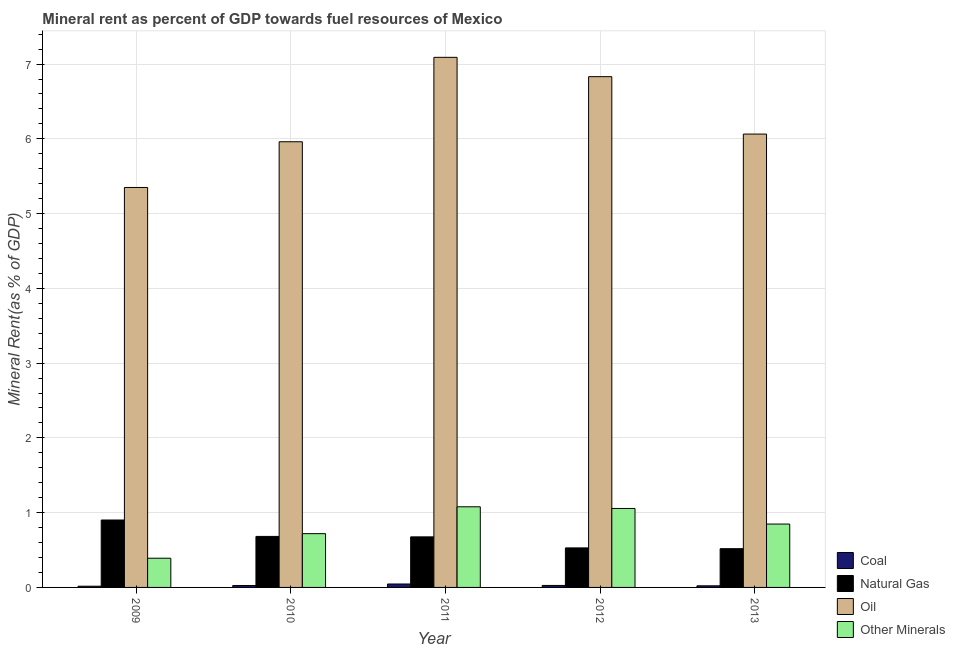How many groups of bars are there?
Give a very brief answer. 5. Are the number of bars per tick equal to the number of legend labels?
Provide a succinct answer. Yes. What is the label of the 4th group of bars from the left?
Make the answer very short. 2012. In how many cases, is the number of bars for a given year not equal to the number of legend labels?
Give a very brief answer. 0. What is the oil rent in 2009?
Offer a terse response. 5.35. Across all years, what is the maximum natural gas rent?
Provide a succinct answer. 0.9. Across all years, what is the minimum natural gas rent?
Offer a very short reply. 0.52. In which year was the oil rent maximum?
Your answer should be very brief. 2011. In which year was the natural gas rent minimum?
Your response must be concise. 2013. What is the total natural gas rent in the graph?
Provide a short and direct response. 3.31. What is the difference between the oil rent in 2011 and that in 2013?
Provide a short and direct response. 1.03. What is the difference between the natural gas rent in 2010 and the oil rent in 2011?
Provide a succinct answer. 0.01. What is the average natural gas rent per year?
Your answer should be compact. 0.66. In how many years, is the oil rent greater than 2.4 %?
Provide a short and direct response. 5. What is the ratio of the  rent of other minerals in 2009 to that in 2012?
Provide a succinct answer. 0.37. Is the natural gas rent in 2009 less than that in 2011?
Make the answer very short. No. What is the difference between the highest and the second highest coal rent?
Your response must be concise. 0.02. What is the difference between the highest and the lowest oil rent?
Your answer should be compact. 1.74. In how many years, is the natural gas rent greater than the average natural gas rent taken over all years?
Offer a terse response. 3. Is the sum of the coal rent in 2010 and 2013 greater than the maximum  rent of other minerals across all years?
Keep it short and to the point. Yes. What does the 2nd bar from the left in 2011 represents?
Offer a terse response. Natural Gas. What does the 1st bar from the right in 2010 represents?
Make the answer very short. Other Minerals. Is it the case that in every year, the sum of the coal rent and natural gas rent is greater than the oil rent?
Your answer should be very brief. No. How many years are there in the graph?
Keep it short and to the point. 5. Are the values on the major ticks of Y-axis written in scientific E-notation?
Offer a terse response. No. How many legend labels are there?
Your answer should be very brief. 4. What is the title of the graph?
Provide a succinct answer. Mineral rent as percent of GDP towards fuel resources of Mexico. What is the label or title of the Y-axis?
Ensure brevity in your answer.  Mineral Rent(as % of GDP). What is the Mineral Rent(as % of GDP) in Coal in 2009?
Make the answer very short. 0.02. What is the Mineral Rent(as % of GDP) of Natural Gas in 2009?
Your answer should be very brief. 0.9. What is the Mineral Rent(as % of GDP) in Oil in 2009?
Keep it short and to the point. 5.35. What is the Mineral Rent(as % of GDP) in Other Minerals in 2009?
Your answer should be compact. 0.39. What is the Mineral Rent(as % of GDP) in Coal in 2010?
Give a very brief answer. 0.03. What is the Mineral Rent(as % of GDP) in Natural Gas in 2010?
Your answer should be compact. 0.68. What is the Mineral Rent(as % of GDP) in Oil in 2010?
Provide a succinct answer. 5.96. What is the Mineral Rent(as % of GDP) of Other Minerals in 2010?
Your answer should be very brief. 0.72. What is the Mineral Rent(as % of GDP) of Coal in 2011?
Your answer should be very brief. 0.05. What is the Mineral Rent(as % of GDP) in Natural Gas in 2011?
Provide a short and direct response. 0.68. What is the Mineral Rent(as % of GDP) in Oil in 2011?
Offer a very short reply. 7.09. What is the Mineral Rent(as % of GDP) of Other Minerals in 2011?
Offer a terse response. 1.08. What is the Mineral Rent(as % of GDP) in Coal in 2012?
Your answer should be very brief. 0.03. What is the Mineral Rent(as % of GDP) in Natural Gas in 2012?
Provide a succinct answer. 0.53. What is the Mineral Rent(as % of GDP) of Oil in 2012?
Keep it short and to the point. 6.83. What is the Mineral Rent(as % of GDP) of Other Minerals in 2012?
Provide a short and direct response. 1.06. What is the Mineral Rent(as % of GDP) of Coal in 2013?
Your response must be concise. 0.02. What is the Mineral Rent(as % of GDP) in Natural Gas in 2013?
Offer a very short reply. 0.52. What is the Mineral Rent(as % of GDP) of Oil in 2013?
Offer a terse response. 6.06. What is the Mineral Rent(as % of GDP) of Other Minerals in 2013?
Your response must be concise. 0.85. Across all years, what is the maximum Mineral Rent(as % of GDP) of Coal?
Your answer should be compact. 0.05. Across all years, what is the maximum Mineral Rent(as % of GDP) of Natural Gas?
Your answer should be compact. 0.9. Across all years, what is the maximum Mineral Rent(as % of GDP) in Oil?
Provide a succinct answer. 7.09. Across all years, what is the maximum Mineral Rent(as % of GDP) in Other Minerals?
Provide a succinct answer. 1.08. Across all years, what is the minimum Mineral Rent(as % of GDP) in Coal?
Ensure brevity in your answer.  0.02. Across all years, what is the minimum Mineral Rent(as % of GDP) of Natural Gas?
Your response must be concise. 0.52. Across all years, what is the minimum Mineral Rent(as % of GDP) in Oil?
Make the answer very short. 5.35. Across all years, what is the minimum Mineral Rent(as % of GDP) of Other Minerals?
Your response must be concise. 0.39. What is the total Mineral Rent(as % of GDP) in Coal in the graph?
Provide a succinct answer. 0.14. What is the total Mineral Rent(as % of GDP) in Natural Gas in the graph?
Make the answer very short. 3.31. What is the total Mineral Rent(as % of GDP) in Oil in the graph?
Offer a terse response. 31.3. What is the total Mineral Rent(as % of GDP) of Other Minerals in the graph?
Provide a short and direct response. 4.09. What is the difference between the Mineral Rent(as % of GDP) in Coal in 2009 and that in 2010?
Provide a short and direct response. -0.01. What is the difference between the Mineral Rent(as % of GDP) in Natural Gas in 2009 and that in 2010?
Ensure brevity in your answer.  0.22. What is the difference between the Mineral Rent(as % of GDP) in Oil in 2009 and that in 2010?
Offer a very short reply. -0.61. What is the difference between the Mineral Rent(as % of GDP) of Other Minerals in 2009 and that in 2010?
Offer a very short reply. -0.33. What is the difference between the Mineral Rent(as % of GDP) in Coal in 2009 and that in 2011?
Offer a very short reply. -0.03. What is the difference between the Mineral Rent(as % of GDP) of Natural Gas in 2009 and that in 2011?
Offer a very short reply. 0.23. What is the difference between the Mineral Rent(as % of GDP) of Oil in 2009 and that in 2011?
Ensure brevity in your answer.  -1.74. What is the difference between the Mineral Rent(as % of GDP) of Other Minerals in 2009 and that in 2011?
Your answer should be very brief. -0.69. What is the difference between the Mineral Rent(as % of GDP) in Coal in 2009 and that in 2012?
Give a very brief answer. -0.01. What is the difference between the Mineral Rent(as % of GDP) of Natural Gas in 2009 and that in 2012?
Your response must be concise. 0.37. What is the difference between the Mineral Rent(as % of GDP) of Oil in 2009 and that in 2012?
Provide a short and direct response. -1.48. What is the difference between the Mineral Rent(as % of GDP) in Other Minerals in 2009 and that in 2012?
Provide a succinct answer. -0.67. What is the difference between the Mineral Rent(as % of GDP) of Coal in 2009 and that in 2013?
Provide a succinct answer. -0.01. What is the difference between the Mineral Rent(as % of GDP) of Natural Gas in 2009 and that in 2013?
Provide a succinct answer. 0.38. What is the difference between the Mineral Rent(as % of GDP) in Oil in 2009 and that in 2013?
Ensure brevity in your answer.  -0.71. What is the difference between the Mineral Rent(as % of GDP) in Other Minerals in 2009 and that in 2013?
Make the answer very short. -0.46. What is the difference between the Mineral Rent(as % of GDP) of Coal in 2010 and that in 2011?
Provide a succinct answer. -0.02. What is the difference between the Mineral Rent(as % of GDP) of Natural Gas in 2010 and that in 2011?
Offer a very short reply. 0.01. What is the difference between the Mineral Rent(as % of GDP) of Oil in 2010 and that in 2011?
Offer a terse response. -1.13. What is the difference between the Mineral Rent(as % of GDP) in Other Minerals in 2010 and that in 2011?
Your answer should be compact. -0.36. What is the difference between the Mineral Rent(as % of GDP) of Coal in 2010 and that in 2012?
Provide a short and direct response. -0. What is the difference between the Mineral Rent(as % of GDP) in Natural Gas in 2010 and that in 2012?
Offer a very short reply. 0.15. What is the difference between the Mineral Rent(as % of GDP) in Oil in 2010 and that in 2012?
Offer a terse response. -0.87. What is the difference between the Mineral Rent(as % of GDP) of Other Minerals in 2010 and that in 2012?
Your answer should be very brief. -0.34. What is the difference between the Mineral Rent(as % of GDP) of Coal in 2010 and that in 2013?
Your response must be concise. 0. What is the difference between the Mineral Rent(as % of GDP) in Natural Gas in 2010 and that in 2013?
Your answer should be compact. 0.16. What is the difference between the Mineral Rent(as % of GDP) of Oil in 2010 and that in 2013?
Your answer should be compact. -0.1. What is the difference between the Mineral Rent(as % of GDP) of Other Minerals in 2010 and that in 2013?
Your answer should be very brief. -0.13. What is the difference between the Mineral Rent(as % of GDP) in Coal in 2011 and that in 2012?
Give a very brief answer. 0.02. What is the difference between the Mineral Rent(as % of GDP) in Natural Gas in 2011 and that in 2012?
Your answer should be compact. 0.15. What is the difference between the Mineral Rent(as % of GDP) in Oil in 2011 and that in 2012?
Ensure brevity in your answer.  0.26. What is the difference between the Mineral Rent(as % of GDP) of Other Minerals in 2011 and that in 2012?
Your answer should be compact. 0.02. What is the difference between the Mineral Rent(as % of GDP) of Coal in 2011 and that in 2013?
Offer a terse response. 0.02. What is the difference between the Mineral Rent(as % of GDP) of Natural Gas in 2011 and that in 2013?
Your answer should be very brief. 0.16. What is the difference between the Mineral Rent(as % of GDP) in Oil in 2011 and that in 2013?
Offer a very short reply. 1.03. What is the difference between the Mineral Rent(as % of GDP) of Other Minerals in 2011 and that in 2013?
Provide a succinct answer. 0.23. What is the difference between the Mineral Rent(as % of GDP) in Coal in 2012 and that in 2013?
Your answer should be very brief. 0. What is the difference between the Mineral Rent(as % of GDP) in Natural Gas in 2012 and that in 2013?
Your response must be concise. 0.01. What is the difference between the Mineral Rent(as % of GDP) in Oil in 2012 and that in 2013?
Your answer should be compact. 0.77. What is the difference between the Mineral Rent(as % of GDP) in Other Minerals in 2012 and that in 2013?
Offer a very short reply. 0.21. What is the difference between the Mineral Rent(as % of GDP) in Coal in 2009 and the Mineral Rent(as % of GDP) in Natural Gas in 2010?
Offer a very short reply. -0.67. What is the difference between the Mineral Rent(as % of GDP) in Coal in 2009 and the Mineral Rent(as % of GDP) in Oil in 2010?
Give a very brief answer. -5.94. What is the difference between the Mineral Rent(as % of GDP) in Coal in 2009 and the Mineral Rent(as % of GDP) in Other Minerals in 2010?
Your response must be concise. -0.7. What is the difference between the Mineral Rent(as % of GDP) of Natural Gas in 2009 and the Mineral Rent(as % of GDP) of Oil in 2010?
Give a very brief answer. -5.06. What is the difference between the Mineral Rent(as % of GDP) of Natural Gas in 2009 and the Mineral Rent(as % of GDP) of Other Minerals in 2010?
Offer a very short reply. 0.18. What is the difference between the Mineral Rent(as % of GDP) in Oil in 2009 and the Mineral Rent(as % of GDP) in Other Minerals in 2010?
Provide a short and direct response. 4.63. What is the difference between the Mineral Rent(as % of GDP) in Coal in 2009 and the Mineral Rent(as % of GDP) in Natural Gas in 2011?
Offer a very short reply. -0.66. What is the difference between the Mineral Rent(as % of GDP) of Coal in 2009 and the Mineral Rent(as % of GDP) of Oil in 2011?
Make the answer very short. -7.07. What is the difference between the Mineral Rent(as % of GDP) in Coal in 2009 and the Mineral Rent(as % of GDP) in Other Minerals in 2011?
Give a very brief answer. -1.06. What is the difference between the Mineral Rent(as % of GDP) of Natural Gas in 2009 and the Mineral Rent(as % of GDP) of Oil in 2011?
Provide a succinct answer. -6.19. What is the difference between the Mineral Rent(as % of GDP) of Natural Gas in 2009 and the Mineral Rent(as % of GDP) of Other Minerals in 2011?
Your answer should be compact. -0.18. What is the difference between the Mineral Rent(as % of GDP) of Oil in 2009 and the Mineral Rent(as % of GDP) of Other Minerals in 2011?
Your answer should be compact. 4.27. What is the difference between the Mineral Rent(as % of GDP) in Coal in 2009 and the Mineral Rent(as % of GDP) in Natural Gas in 2012?
Your response must be concise. -0.51. What is the difference between the Mineral Rent(as % of GDP) in Coal in 2009 and the Mineral Rent(as % of GDP) in Oil in 2012?
Your answer should be very brief. -6.82. What is the difference between the Mineral Rent(as % of GDP) of Coal in 2009 and the Mineral Rent(as % of GDP) of Other Minerals in 2012?
Offer a very short reply. -1.04. What is the difference between the Mineral Rent(as % of GDP) of Natural Gas in 2009 and the Mineral Rent(as % of GDP) of Oil in 2012?
Keep it short and to the point. -5.93. What is the difference between the Mineral Rent(as % of GDP) in Natural Gas in 2009 and the Mineral Rent(as % of GDP) in Other Minerals in 2012?
Offer a terse response. -0.15. What is the difference between the Mineral Rent(as % of GDP) of Oil in 2009 and the Mineral Rent(as % of GDP) of Other Minerals in 2012?
Keep it short and to the point. 4.29. What is the difference between the Mineral Rent(as % of GDP) of Coal in 2009 and the Mineral Rent(as % of GDP) of Natural Gas in 2013?
Offer a very short reply. -0.5. What is the difference between the Mineral Rent(as % of GDP) in Coal in 2009 and the Mineral Rent(as % of GDP) in Oil in 2013?
Give a very brief answer. -6.05. What is the difference between the Mineral Rent(as % of GDP) in Coal in 2009 and the Mineral Rent(as % of GDP) in Other Minerals in 2013?
Provide a succinct answer. -0.83. What is the difference between the Mineral Rent(as % of GDP) of Natural Gas in 2009 and the Mineral Rent(as % of GDP) of Oil in 2013?
Ensure brevity in your answer.  -5.16. What is the difference between the Mineral Rent(as % of GDP) of Natural Gas in 2009 and the Mineral Rent(as % of GDP) of Other Minerals in 2013?
Your answer should be very brief. 0.05. What is the difference between the Mineral Rent(as % of GDP) in Oil in 2009 and the Mineral Rent(as % of GDP) in Other Minerals in 2013?
Your response must be concise. 4.5. What is the difference between the Mineral Rent(as % of GDP) of Coal in 2010 and the Mineral Rent(as % of GDP) of Natural Gas in 2011?
Give a very brief answer. -0.65. What is the difference between the Mineral Rent(as % of GDP) in Coal in 2010 and the Mineral Rent(as % of GDP) in Oil in 2011?
Provide a succinct answer. -7.06. What is the difference between the Mineral Rent(as % of GDP) in Coal in 2010 and the Mineral Rent(as % of GDP) in Other Minerals in 2011?
Give a very brief answer. -1.05. What is the difference between the Mineral Rent(as % of GDP) of Natural Gas in 2010 and the Mineral Rent(as % of GDP) of Oil in 2011?
Keep it short and to the point. -6.41. What is the difference between the Mineral Rent(as % of GDP) of Natural Gas in 2010 and the Mineral Rent(as % of GDP) of Other Minerals in 2011?
Provide a short and direct response. -0.4. What is the difference between the Mineral Rent(as % of GDP) in Oil in 2010 and the Mineral Rent(as % of GDP) in Other Minerals in 2011?
Offer a terse response. 4.88. What is the difference between the Mineral Rent(as % of GDP) of Coal in 2010 and the Mineral Rent(as % of GDP) of Natural Gas in 2012?
Keep it short and to the point. -0.5. What is the difference between the Mineral Rent(as % of GDP) in Coal in 2010 and the Mineral Rent(as % of GDP) in Oil in 2012?
Offer a very short reply. -6.81. What is the difference between the Mineral Rent(as % of GDP) of Coal in 2010 and the Mineral Rent(as % of GDP) of Other Minerals in 2012?
Keep it short and to the point. -1.03. What is the difference between the Mineral Rent(as % of GDP) in Natural Gas in 2010 and the Mineral Rent(as % of GDP) in Oil in 2012?
Your answer should be very brief. -6.15. What is the difference between the Mineral Rent(as % of GDP) of Natural Gas in 2010 and the Mineral Rent(as % of GDP) of Other Minerals in 2012?
Offer a terse response. -0.37. What is the difference between the Mineral Rent(as % of GDP) in Oil in 2010 and the Mineral Rent(as % of GDP) in Other Minerals in 2012?
Your answer should be very brief. 4.9. What is the difference between the Mineral Rent(as % of GDP) in Coal in 2010 and the Mineral Rent(as % of GDP) in Natural Gas in 2013?
Your answer should be very brief. -0.49. What is the difference between the Mineral Rent(as % of GDP) of Coal in 2010 and the Mineral Rent(as % of GDP) of Oil in 2013?
Offer a very short reply. -6.04. What is the difference between the Mineral Rent(as % of GDP) of Coal in 2010 and the Mineral Rent(as % of GDP) of Other Minerals in 2013?
Ensure brevity in your answer.  -0.82. What is the difference between the Mineral Rent(as % of GDP) in Natural Gas in 2010 and the Mineral Rent(as % of GDP) in Oil in 2013?
Your answer should be compact. -5.38. What is the difference between the Mineral Rent(as % of GDP) of Natural Gas in 2010 and the Mineral Rent(as % of GDP) of Other Minerals in 2013?
Your response must be concise. -0.17. What is the difference between the Mineral Rent(as % of GDP) of Oil in 2010 and the Mineral Rent(as % of GDP) of Other Minerals in 2013?
Give a very brief answer. 5.11. What is the difference between the Mineral Rent(as % of GDP) in Coal in 2011 and the Mineral Rent(as % of GDP) in Natural Gas in 2012?
Give a very brief answer. -0.48. What is the difference between the Mineral Rent(as % of GDP) of Coal in 2011 and the Mineral Rent(as % of GDP) of Oil in 2012?
Your answer should be very brief. -6.79. What is the difference between the Mineral Rent(as % of GDP) in Coal in 2011 and the Mineral Rent(as % of GDP) in Other Minerals in 2012?
Provide a short and direct response. -1.01. What is the difference between the Mineral Rent(as % of GDP) of Natural Gas in 2011 and the Mineral Rent(as % of GDP) of Oil in 2012?
Keep it short and to the point. -6.16. What is the difference between the Mineral Rent(as % of GDP) in Natural Gas in 2011 and the Mineral Rent(as % of GDP) in Other Minerals in 2012?
Make the answer very short. -0.38. What is the difference between the Mineral Rent(as % of GDP) in Oil in 2011 and the Mineral Rent(as % of GDP) in Other Minerals in 2012?
Give a very brief answer. 6.03. What is the difference between the Mineral Rent(as % of GDP) in Coal in 2011 and the Mineral Rent(as % of GDP) in Natural Gas in 2013?
Make the answer very short. -0.47. What is the difference between the Mineral Rent(as % of GDP) in Coal in 2011 and the Mineral Rent(as % of GDP) in Oil in 2013?
Offer a very short reply. -6.02. What is the difference between the Mineral Rent(as % of GDP) in Coal in 2011 and the Mineral Rent(as % of GDP) in Other Minerals in 2013?
Offer a terse response. -0.8. What is the difference between the Mineral Rent(as % of GDP) of Natural Gas in 2011 and the Mineral Rent(as % of GDP) of Oil in 2013?
Provide a short and direct response. -5.39. What is the difference between the Mineral Rent(as % of GDP) of Natural Gas in 2011 and the Mineral Rent(as % of GDP) of Other Minerals in 2013?
Your answer should be compact. -0.17. What is the difference between the Mineral Rent(as % of GDP) of Oil in 2011 and the Mineral Rent(as % of GDP) of Other Minerals in 2013?
Your answer should be very brief. 6.24. What is the difference between the Mineral Rent(as % of GDP) of Coal in 2012 and the Mineral Rent(as % of GDP) of Natural Gas in 2013?
Provide a succinct answer. -0.49. What is the difference between the Mineral Rent(as % of GDP) in Coal in 2012 and the Mineral Rent(as % of GDP) in Oil in 2013?
Your answer should be very brief. -6.04. What is the difference between the Mineral Rent(as % of GDP) of Coal in 2012 and the Mineral Rent(as % of GDP) of Other Minerals in 2013?
Make the answer very short. -0.82. What is the difference between the Mineral Rent(as % of GDP) in Natural Gas in 2012 and the Mineral Rent(as % of GDP) in Oil in 2013?
Offer a terse response. -5.54. What is the difference between the Mineral Rent(as % of GDP) in Natural Gas in 2012 and the Mineral Rent(as % of GDP) in Other Minerals in 2013?
Provide a succinct answer. -0.32. What is the difference between the Mineral Rent(as % of GDP) in Oil in 2012 and the Mineral Rent(as % of GDP) in Other Minerals in 2013?
Your answer should be compact. 5.98. What is the average Mineral Rent(as % of GDP) in Coal per year?
Make the answer very short. 0.03. What is the average Mineral Rent(as % of GDP) of Natural Gas per year?
Provide a succinct answer. 0.66. What is the average Mineral Rent(as % of GDP) in Oil per year?
Provide a short and direct response. 6.26. What is the average Mineral Rent(as % of GDP) of Other Minerals per year?
Keep it short and to the point. 0.82. In the year 2009, what is the difference between the Mineral Rent(as % of GDP) of Coal and Mineral Rent(as % of GDP) of Natural Gas?
Your response must be concise. -0.89. In the year 2009, what is the difference between the Mineral Rent(as % of GDP) in Coal and Mineral Rent(as % of GDP) in Oil?
Offer a terse response. -5.33. In the year 2009, what is the difference between the Mineral Rent(as % of GDP) in Coal and Mineral Rent(as % of GDP) in Other Minerals?
Your answer should be compact. -0.37. In the year 2009, what is the difference between the Mineral Rent(as % of GDP) of Natural Gas and Mineral Rent(as % of GDP) of Oil?
Keep it short and to the point. -4.45. In the year 2009, what is the difference between the Mineral Rent(as % of GDP) in Natural Gas and Mineral Rent(as % of GDP) in Other Minerals?
Keep it short and to the point. 0.51. In the year 2009, what is the difference between the Mineral Rent(as % of GDP) of Oil and Mineral Rent(as % of GDP) of Other Minerals?
Offer a terse response. 4.96. In the year 2010, what is the difference between the Mineral Rent(as % of GDP) in Coal and Mineral Rent(as % of GDP) in Natural Gas?
Your answer should be compact. -0.66. In the year 2010, what is the difference between the Mineral Rent(as % of GDP) in Coal and Mineral Rent(as % of GDP) in Oil?
Offer a very short reply. -5.94. In the year 2010, what is the difference between the Mineral Rent(as % of GDP) in Coal and Mineral Rent(as % of GDP) in Other Minerals?
Your answer should be compact. -0.69. In the year 2010, what is the difference between the Mineral Rent(as % of GDP) of Natural Gas and Mineral Rent(as % of GDP) of Oil?
Make the answer very short. -5.28. In the year 2010, what is the difference between the Mineral Rent(as % of GDP) in Natural Gas and Mineral Rent(as % of GDP) in Other Minerals?
Give a very brief answer. -0.04. In the year 2010, what is the difference between the Mineral Rent(as % of GDP) in Oil and Mineral Rent(as % of GDP) in Other Minerals?
Provide a succinct answer. 5.24. In the year 2011, what is the difference between the Mineral Rent(as % of GDP) of Coal and Mineral Rent(as % of GDP) of Natural Gas?
Your answer should be compact. -0.63. In the year 2011, what is the difference between the Mineral Rent(as % of GDP) of Coal and Mineral Rent(as % of GDP) of Oil?
Ensure brevity in your answer.  -7.04. In the year 2011, what is the difference between the Mineral Rent(as % of GDP) in Coal and Mineral Rent(as % of GDP) in Other Minerals?
Offer a terse response. -1.03. In the year 2011, what is the difference between the Mineral Rent(as % of GDP) in Natural Gas and Mineral Rent(as % of GDP) in Oil?
Your answer should be compact. -6.41. In the year 2011, what is the difference between the Mineral Rent(as % of GDP) of Natural Gas and Mineral Rent(as % of GDP) of Other Minerals?
Make the answer very short. -0.4. In the year 2011, what is the difference between the Mineral Rent(as % of GDP) of Oil and Mineral Rent(as % of GDP) of Other Minerals?
Offer a very short reply. 6.01. In the year 2012, what is the difference between the Mineral Rent(as % of GDP) of Coal and Mineral Rent(as % of GDP) of Natural Gas?
Your answer should be very brief. -0.5. In the year 2012, what is the difference between the Mineral Rent(as % of GDP) in Coal and Mineral Rent(as % of GDP) in Oil?
Give a very brief answer. -6.81. In the year 2012, what is the difference between the Mineral Rent(as % of GDP) in Coal and Mineral Rent(as % of GDP) in Other Minerals?
Keep it short and to the point. -1.03. In the year 2012, what is the difference between the Mineral Rent(as % of GDP) of Natural Gas and Mineral Rent(as % of GDP) of Oil?
Keep it short and to the point. -6.3. In the year 2012, what is the difference between the Mineral Rent(as % of GDP) of Natural Gas and Mineral Rent(as % of GDP) of Other Minerals?
Keep it short and to the point. -0.53. In the year 2012, what is the difference between the Mineral Rent(as % of GDP) in Oil and Mineral Rent(as % of GDP) in Other Minerals?
Your answer should be very brief. 5.78. In the year 2013, what is the difference between the Mineral Rent(as % of GDP) in Coal and Mineral Rent(as % of GDP) in Natural Gas?
Your answer should be compact. -0.5. In the year 2013, what is the difference between the Mineral Rent(as % of GDP) in Coal and Mineral Rent(as % of GDP) in Oil?
Provide a short and direct response. -6.04. In the year 2013, what is the difference between the Mineral Rent(as % of GDP) of Coal and Mineral Rent(as % of GDP) of Other Minerals?
Your answer should be compact. -0.83. In the year 2013, what is the difference between the Mineral Rent(as % of GDP) of Natural Gas and Mineral Rent(as % of GDP) of Oil?
Keep it short and to the point. -5.55. In the year 2013, what is the difference between the Mineral Rent(as % of GDP) in Natural Gas and Mineral Rent(as % of GDP) in Other Minerals?
Your answer should be very brief. -0.33. In the year 2013, what is the difference between the Mineral Rent(as % of GDP) in Oil and Mineral Rent(as % of GDP) in Other Minerals?
Keep it short and to the point. 5.22. What is the ratio of the Mineral Rent(as % of GDP) in Coal in 2009 to that in 2010?
Offer a terse response. 0.64. What is the ratio of the Mineral Rent(as % of GDP) in Natural Gas in 2009 to that in 2010?
Your answer should be very brief. 1.32. What is the ratio of the Mineral Rent(as % of GDP) in Oil in 2009 to that in 2010?
Your answer should be compact. 0.9. What is the ratio of the Mineral Rent(as % of GDP) in Other Minerals in 2009 to that in 2010?
Your answer should be compact. 0.54. What is the ratio of the Mineral Rent(as % of GDP) in Coal in 2009 to that in 2011?
Make the answer very short. 0.35. What is the ratio of the Mineral Rent(as % of GDP) of Oil in 2009 to that in 2011?
Provide a short and direct response. 0.75. What is the ratio of the Mineral Rent(as % of GDP) of Other Minerals in 2009 to that in 2011?
Provide a short and direct response. 0.36. What is the ratio of the Mineral Rent(as % of GDP) in Coal in 2009 to that in 2012?
Ensure brevity in your answer.  0.61. What is the ratio of the Mineral Rent(as % of GDP) in Natural Gas in 2009 to that in 2012?
Ensure brevity in your answer.  1.71. What is the ratio of the Mineral Rent(as % of GDP) in Oil in 2009 to that in 2012?
Provide a short and direct response. 0.78. What is the ratio of the Mineral Rent(as % of GDP) of Other Minerals in 2009 to that in 2012?
Offer a very short reply. 0.37. What is the ratio of the Mineral Rent(as % of GDP) in Coal in 2009 to that in 2013?
Your answer should be very brief. 0.75. What is the ratio of the Mineral Rent(as % of GDP) of Natural Gas in 2009 to that in 2013?
Keep it short and to the point. 1.74. What is the ratio of the Mineral Rent(as % of GDP) of Oil in 2009 to that in 2013?
Your answer should be compact. 0.88. What is the ratio of the Mineral Rent(as % of GDP) in Other Minerals in 2009 to that in 2013?
Your answer should be compact. 0.46. What is the ratio of the Mineral Rent(as % of GDP) in Coal in 2010 to that in 2011?
Provide a short and direct response. 0.55. What is the ratio of the Mineral Rent(as % of GDP) of Natural Gas in 2010 to that in 2011?
Offer a very short reply. 1.01. What is the ratio of the Mineral Rent(as % of GDP) of Oil in 2010 to that in 2011?
Your response must be concise. 0.84. What is the ratio of the Mineral Rent(as % of GDP) of Other Minerals in 2010 to that in 2011?
Ensure brevity in your answer.  0.67. What is the ratio of the Mineral Rent(as % of GDP) in Coal in 2010 to that in 2012?
Your answer should be compact. 0.96. What is the ratio of the Mineral Rent(as % of GDP) in Natural Gas in 2010 to that in 2012?
Make the answer very short. 1.29. What is the ratio of the Mineral Rent(as % of GDP) of Oil in 2010 to that in 2012?
Your answer should be very brief. 0.87. What is the ratio of the Mineral Rent(as % of GDP) of Other Minerals in 2010 to that in 2012?
Your response must be concise. 0.68. What is the ratio of the Mineral Rent(as % of GDP) of Coal in 2010 to that in 2013?
Keep it short and to the point. 1.18. What is the ratio of the Mineral Rent(as % of GDP) of Natural Gas in 2010 to that in 2013?
Offer a very short reply. 1.32. What is the ratio of the Mineral Rent(as % of GDP) of Other Minerals in 2010 to that in 2013?
Your response must be concise. 0.85. What is the ratio of the Mineral Rent(as % of GDP) in Coal in 2011 to that in 2012?
Provide a succinct answer. 1.73. What is the ratio of the Mineral Rent(as % of GDP) in Natural Gas in 2011 to that in 2012?
Ensure brevity in your answer.  1.28. What is the ratio of the Mineral Rent(as % of GDP) in Oil in 2011 to that in 2012?
Provide a short and direct response. 1.04. What is the ratio of the Mineral Rent(as % of GDP) of Other Minerals in 2011 to that in 2012?
Provide a succinct answer. 1.02. What is the ratio of the Mineral Rent(as % of GDP) in Coal in 2011 to that in 2013?
Your answer should be very brief. 2.12. What is the ratio of the Mineral Rent(as % of GDP) in Natural Gas in 2011 to that in 2013?
Offer a very short reply. 1.3. What is the ratio of the Mineral Rent(as % of GDP) in Oil in 2011 to that in 2013?
Your response must be concise. 1.17. What is the ratio of the Mineral Rent(as % of GDP) in Other Minerals in 2011 to that in 2013?
Make the answer very short. 1.27. What is the ratio of the Mineral Rent(as % of GDP) of Coal in 2012 to that in 2013?
Ensure brevity in your answer.  1.23. What is the ratio of the Mineral Rent(as % of GDP) in Natural Gas in 2012 to that in 2013?
Give a very brief answer. 1.02. What is the ratio of the Mineral Rent(as % of GDP) in Oil in 2012 to that in 2013?
Make the answer very short. 1.13. What is the ratio of the Mineral Rent(as % of GDP) in Other Minerals in 2012 to that in 2013?
Your response must be concise. 1.25. What is the difference between the highest and the second highest Mineral Rent(as % of GDP) of Coal?
Give a very brief answer. 0.02. What is the difference between the highest and the second highest Mineral Rent(as % of GDP) of Natural Gas?
Provide a succinct answer. 0.22. What is the difference between the highest and the second highest Mineral Rent(as % of GDP) in Oil?
Keep it short and to the point. 0.26. What is the difference between the highest and the second highest Mineral Rent(as % of GDP) in Other Minerals?
Give a very brief answer. 0.02. What is the difference between the highest and the lowest Mineral Rent(as % of GDP) of Coal?
Give a very brief answer. 0.03. What is the difference between the highest and the lowest Mineral Rent(as % of GDP) of Natural Gas?
Your answer should be compact. 0.38. What is the difference between the highest and the lowest Mineral Rent(as % of GDP) of Oil?
Give a very brief answer. 1.74. What is the difference between the highest and the lowest Mineral Rent(as % of GDP) of Other Minerals?
Your answer should be very brief. 0.69. 